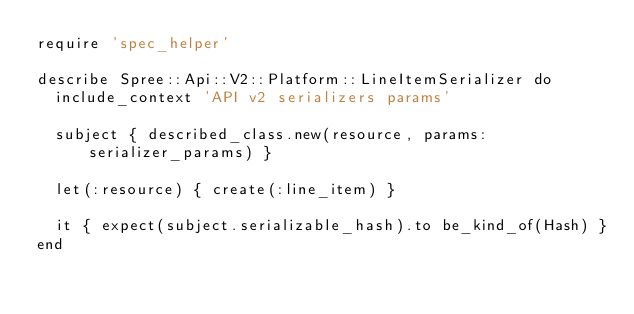<code> <loc_0><loc_0><loc_500><loc_500><_Ruby_>require 'spec_helper'

describe Spree::Api::V2::Platform::LineItemSerializer do
  include_context 'API v2 serializers params'

  subject { described_class.new(resource, params: serializer_params) }

  let(:resource) { create(:line_item) }

  it { expect(subject.serializable_hash).to be_kind_of(Hash) }
end</code> 